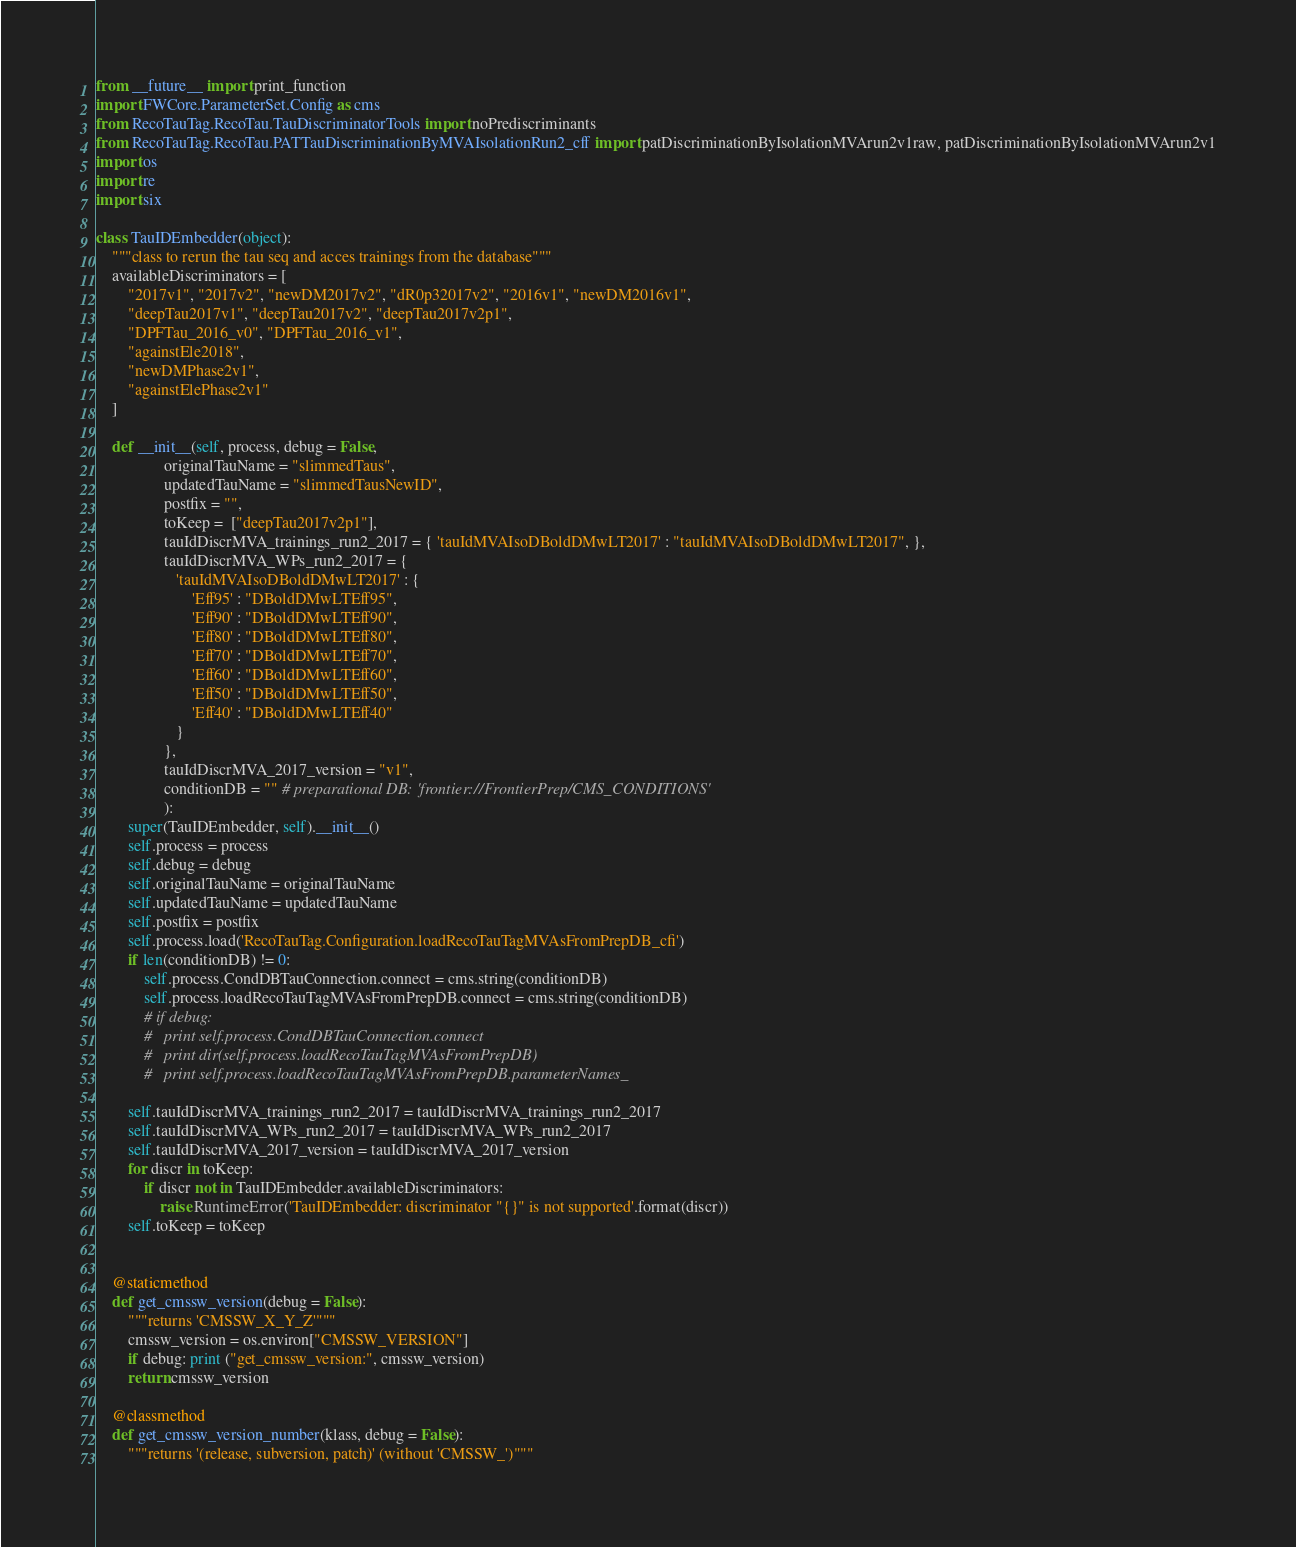<code> <loc_0><loc_0><loc_500><loc_500><_Python_>from __future__ import print_function
import FWCore.ParameterSet.Config as cms
from RecoTauTag.RecoTau.TauDiscriminatorTools import noPrediscriminants
from RecoTauTag.RecoTau.PATTauDiscriminationByMVAIsolationRun2_cff import patDiscriminationByIsolationMVArun2v1raw, patDiscriminationByIsolationMVArun2v1
import os
import re
import six

class TauIDEmbedder(object):
    """class to rerun the tau seq and acces trainings from the database"""
    availableDiscriminators = [
        "2017v1", "2017v2", "newDM2017v2", "dR0p32017v2", "2016v1", "newDM2016v1",
        "deepTau2017v1", "deepTau2017v2", "deepTau2017v2p1",
        "DPFTau_2016_v0", "DPFTau_2016_v1",
        "againstEle2018",
        "newDMPhase2v1",
        "againstElePhase2v1"
    ]

    def __init__(self, process, debug = False,
                 originalTauName = "slimmedTaus",
                 updatedTauName = "slimmedTausNewID",
                 postfix = "",
                 toKeep =  ["deepTau2017v2p1"],
                 tauIdDiscrMVA_trainings_run2_2017 = { 'tauIdMVAIsoDBoldDMwLT2017' : "tauIdMVAIsoDBoldDMwLT2017", },
                 tauIdDiscrMVA_WPs_run2_2017 = {
                    'tauIdMVAIsoDBoldDMwLT2017' : {
                        'Eff95' : "DBoldDMwLTEff95",
                        'Eff90' : "DBoldDMwLTEff90",
                        'Eff80' : "DBoldDMwLTEff80",
                        'Eff70' : "DBoldDMwLTEff70",
                        'Eff60' : "DBoldDMwLTEff60",
                        'Eff50' : "DBoldDMwLTEff50",
                        'Eff40' : "DBoldDMwLTEff40"
                    }
                 },
                 tauIdDiscrMVA_2017_version = "v1",
                 conditionDB = "" # preparational DB: 'frontier://FrontierPrep/CMS_CONDITIONS'
                 ):
        super(TauIDEmbedder, self).__init__()
        self.process = process
        self.debug = debug
        self.originalTauName = originalTauName
        self.updatedTauName = updatedTauName
        self.postfix = postfix
        self.process.load('RecoTauTag.Configuration.loadRecoTauTagMVAsFromPrepDB_cfi')
        if len(conditionDB) != 0:
            self.process.CondDBTauConnection.connect = cms.string(conditionDB)
            self.process.loadRecoTauTagMVAsFromPrepDB.connect = cms.string(conditionDB)
            # if debug:
            # 	print self.process.CondDBTauConnection.connect
            # 	print dir(self.process.loadRecoTauTagMVAsFromPrepDB)
            # 	print self.process.loadRecoTauTagMVAsFromPrepDB.parameterNames_

        self.tauIdDiscrMVA_trainings_run2_2017 = tauIdDiscrMVA_trainings_run2_2017
        self.tauIdDiscrMVA_WPs_run2_2017 = tauIdDiscrMVA_WPs_run2_2017
        self.tauIdDiscrMVA_2017_version = tauIdDiscrMVA_2017_version
        for discr in toKeep:
            if discr not in TauIDEmbedder.availableDiscriminators:
                raise RuntimeError('TauIDEmbedder: discriminator "{}" is not supported'.format(discr))
        self.toKeep = toKeep

    
    @staticmethod
    def get_cmssw_version(debug = False):
        """returns 'CMSSW_X_Y_Z'"""
        cmssw_version = os.environ["CMSSW_VERSION"]
        if debug: print ("get_cmssw_version:", cmssw_version)
        return cmssw_version

    @classmethod
    def get_cmssw_version_number(klass, debug = False):
        """returns '(release, subversion, patch)' (without 'CMSSW_')"""</code> 